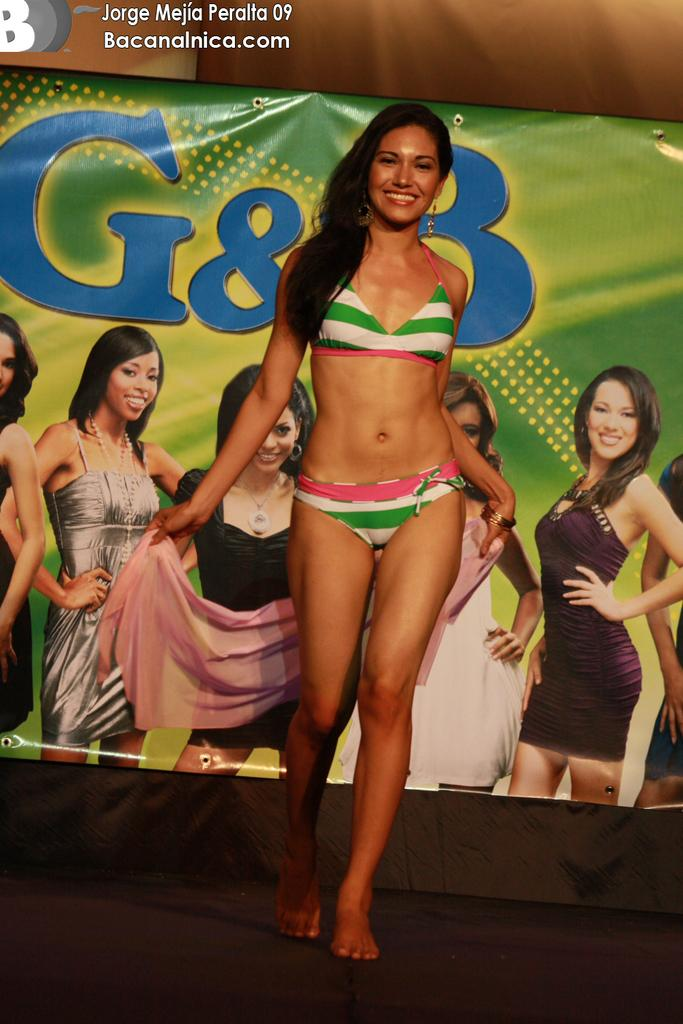What is the main subject of the image? There is a lady walking in the center of the image. What can be seen in the background of the image? There is a banner in the background of the image. What is the color of the surface at the bottom of the image? There is a black color surface at the bottom of the image. What type of sound can be heard coming from the lady in the image? There is no sound present in the image, so it cannot be determined what, if any, sound might be heard. 